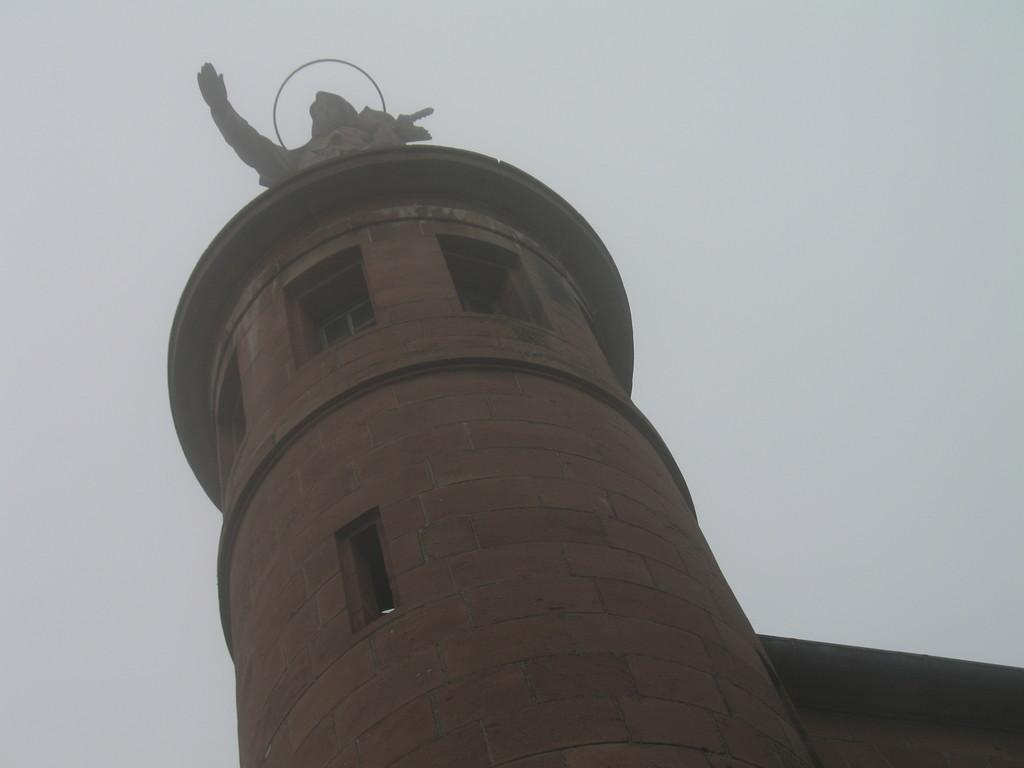What type of structure is present in the image? There is a building in the image. Is there any additional feature on the building? Yes, there is a statue on the building. What can be seen in the background of the image? The sky is visible in the image. What type of yam is growing in the circle on the building? There is no yam or circle present on the building in the image. 